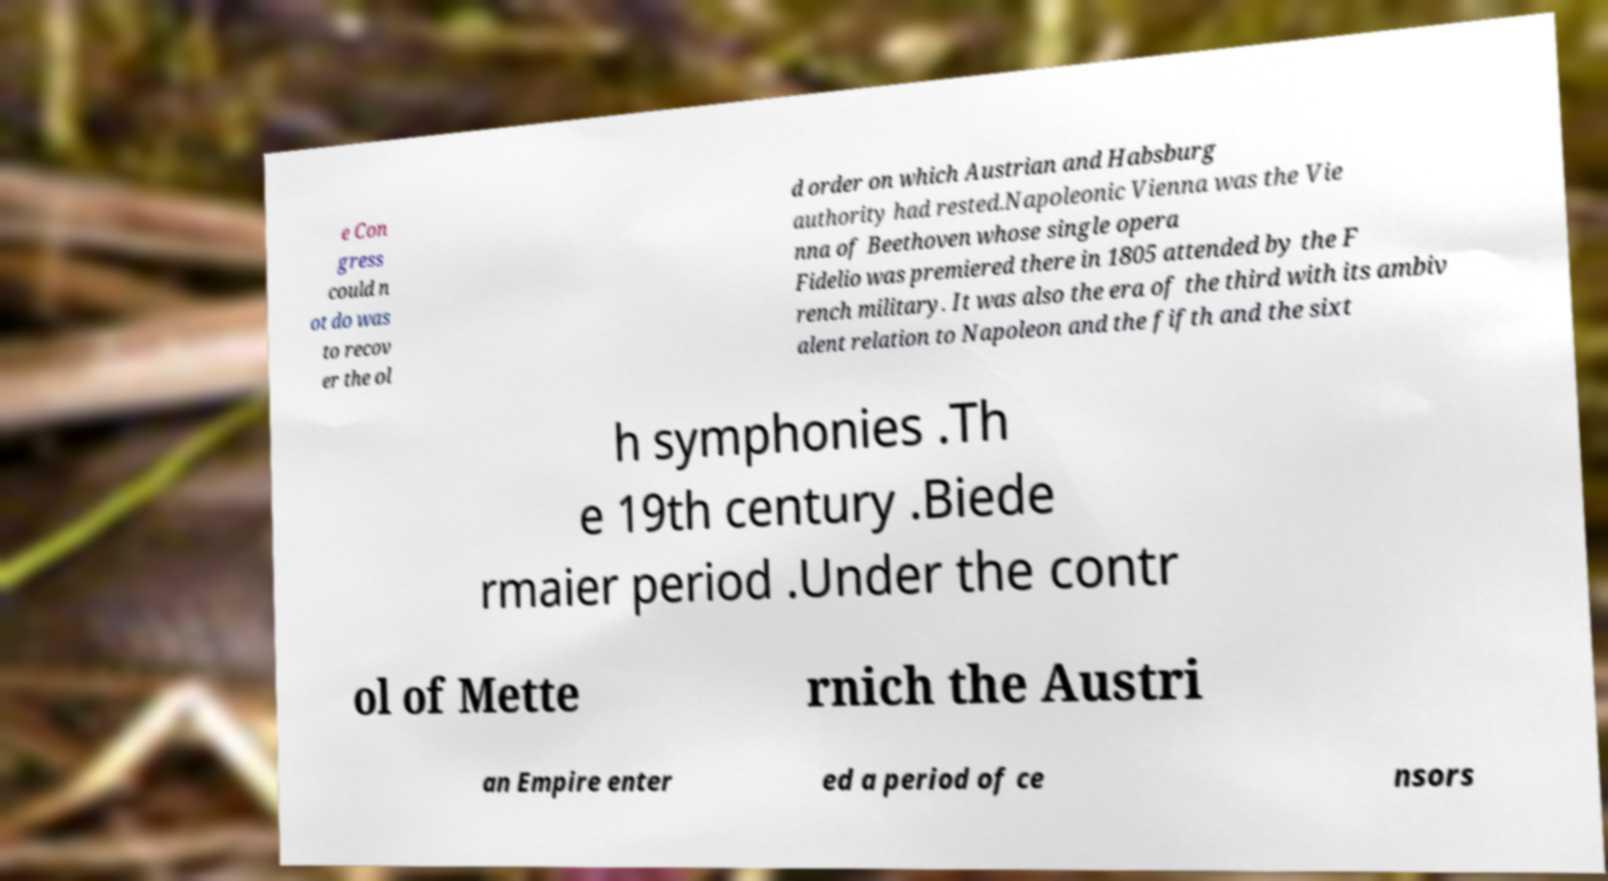Could you extract and type out the text from this image? e Con gress could n ot do was to recov er the ol d order on which Austrian and Habsburg authority had rested.Napoleonic Vienna was the Vie nna of Beethoven whose single opera Fidelio was premiered there in 1805 attended by the F rench military. It was also the era of the third with its ambiv alent relation to Napoleon and the fifth and the sixt h symphonies .Th e 19th century .Biede rmaier period .Under the contr ol of Mette rnich the Austri an Empire enter ed a period of ce nsors 